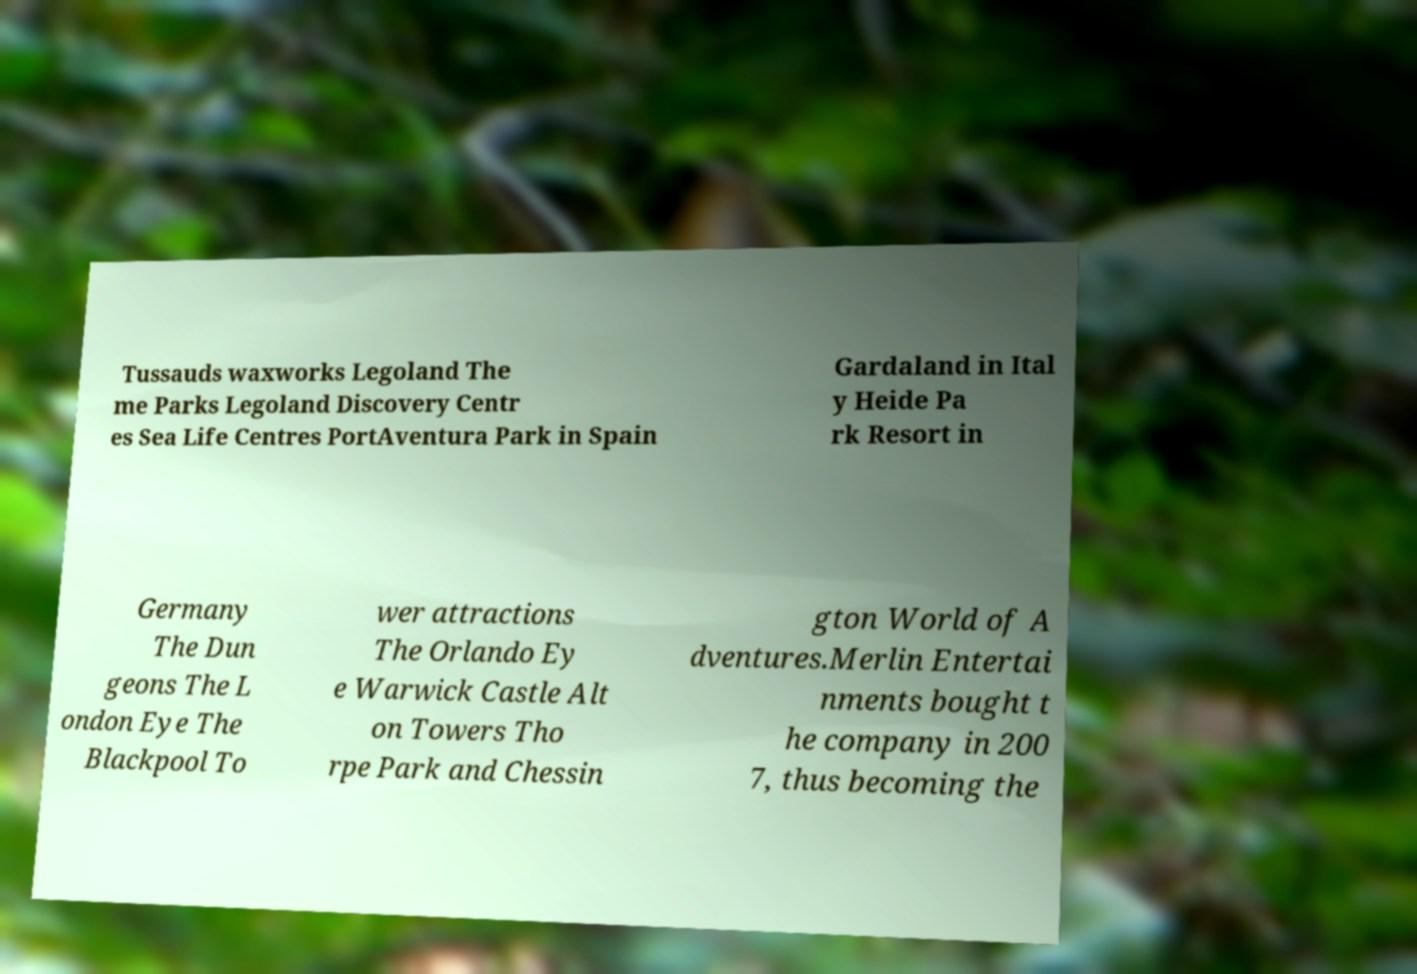Could you assist in decoding the text presented in this image and type it out clearly? Tussauds waxworks Legoland The me Parks Legoland Discovery Centr es Sea Life Centres PortAventura Park in Spain Gardaland in Ital y Heide Pa rk Resort in Germany The Dun geons The L ondon Eye The Blackpool To wer attractions The Orlando Ey e Warwick Castle Alt on Towers Tho rpe Park and Chessin gton World of A dventures.Merlin Entertai nments bought t he company in 200 7, thus becoming the 